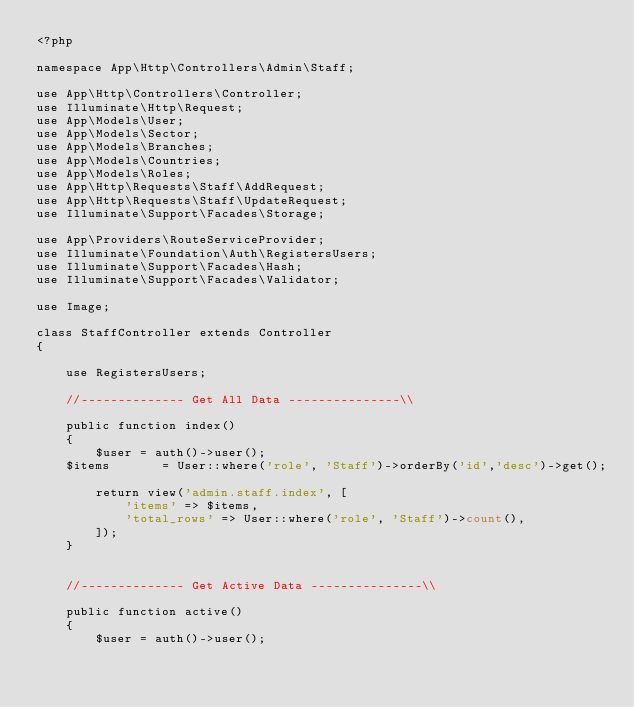<code> <loc_0><loc_0><loc_500><loc_500><_PHP_><?php

namespace App\Http\Controllers\Admin\Staff;

use App\Http\Controllers\Controller;
use Illuminate\Http\Request;
use App\Models\User;
use App\Models\Sector;
use App\Models\Branches;
use App\Models\Countries;
use App\Models\Roles;
use App\Http\Requests\Staff\AddRequest;
use App\Http\Requests\Staff\UpdateRequest;
use Illuminate\Support\Facades\Storage;

use App\Providers\RouteServiceProvider;
use Illuminate\Foundation\Auth\RegistersUsers;
use Illuminate\Support\Facades\Hash;
use Illuminate\Support\Facades\Validator;

use Image;

class StaffController extends Controller
{

    use RegistersUsers;

    //-------------- Get All Data ---------------\\

    public function index()
    {
        $user = auth()->user();
		$items       = User::where('role', 'Staff')->orderBy('id','desc')->get();

        return view('admin.staff.index', [
            'items' => $items,
            'total_rows' => User::where('role', 'Staff')->count(),
        ]);
    }


    //-------------- Get Active Data ---------------\\

    public function active()
    {
        $user = auth()->user();</code> 